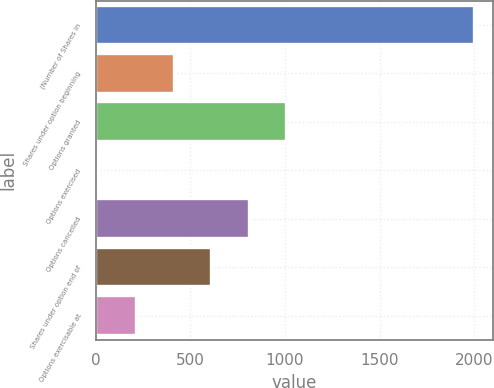<chart> <loc_0><loc_0><loc_500><loc_500><bar_chart><fcel>(Number of Shares in<fcel>Shares under option beginning<fcel>Options granted<fcel>Options exercised<fcel>Options cancelled<fcel>Shares under option end of<fcel>Options exercisable at<nl><fcel>2000<fcel>412<fcel>1007.5<fcel>15<fcel>809<fcel>610.5<fcel>213.5<nl></chart> 